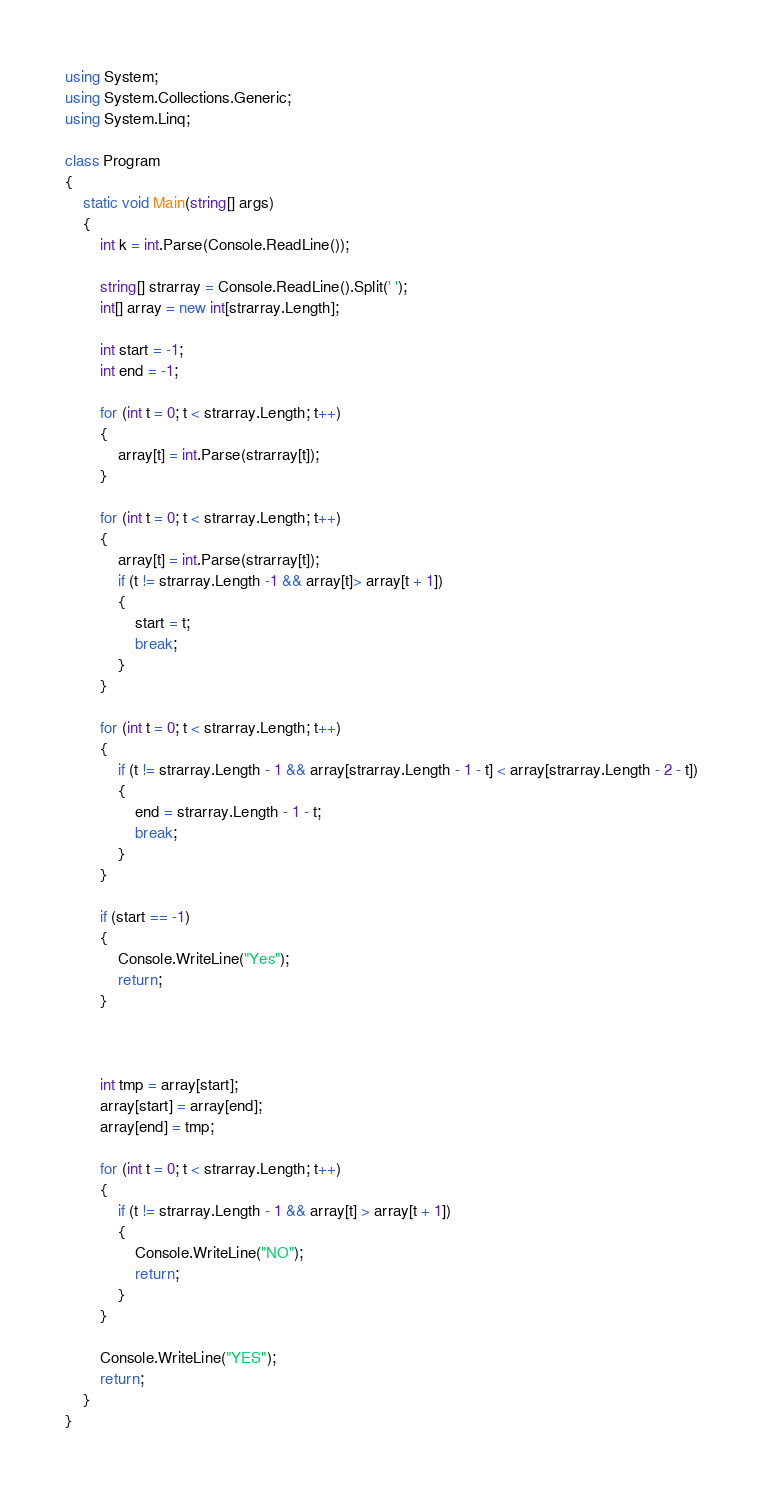<code> <loc_0><loc_0><loc_500><loc_500><_C#_>using System;
using System.Collections.Generic;
using System.Linq;

class Program
{
    static void Main(string[] args)
    {
        int k = int.Parse(Console.ReadLine());

        string[] strarray = Console.ReadLine().Split(' ');
        int[] array = new int[strarray.Length];

        int start = -1;
        int end = -1;

        for (int t = 0; t < strarray.Length; t++)
        {
            array[t] = int.Parse(strarray[t]);
        }

        for (int t = 0; t < strarray.Length; t++)
        {
            array[t] = int.Parse(strarray[t]);
            if (t != strarray.Length -1 && array[t]> array[t + 1])
            {
                start = t;
                break;
            }
        }

        for (int t = 0; t < strarray.Length; t++)
        {
            if (t != strarray.Length - 1 && array[strarray.Length - 1 - t] < array[strarray.Length - 2 - t])
            {
                end = strarray.Length - 1 - t;
                break;
            }
        }

        if (start == -1)
        {
            Console.WriteLine("Yes");
            return;
        }



        int tmp = array[start];
        array[start] = array[end];
        array[end] = tmp;

        for (int t = 0; t < strarray.Length; t++)
        {
            if (t != strarray.Length - 1 && array[t] > array[t + 1])
            {
                Console.WriteLine("NO");
                return;
            }
        }

        Console.WriteLine("YES");
        return;
    }
}
</code> 